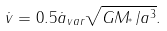<formula> <loc_0><loc_0><loc_500><loc_500>\dot { v } = 0 . 5 \dot { a } _ { v a r } \sqrt { G M _ { ^ { * } } / a ^ { 3 } } .</formula> 